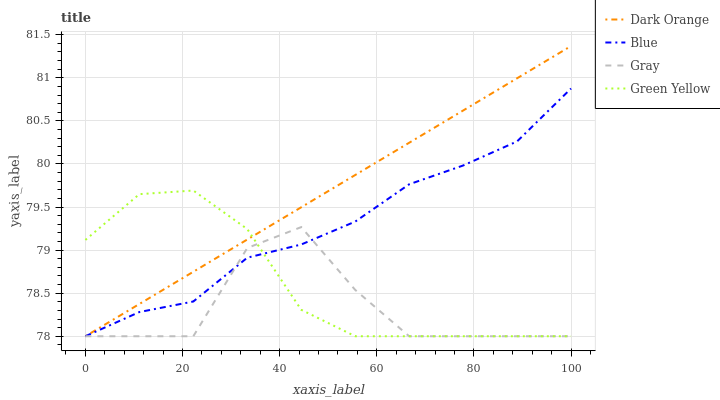Does Green Yellow have the minimum area under the curve?
Answer yes or no. No. Does Green Yellow have the maximum area under the curve?
Answer yes or no. No. Is Green Yellow the smoothest?
Answer yes or no. No. Is Green Yellow the roughest?
Answer yes or no. No. Does Green Yellow have the highest value?
Answer yes or no. No. 